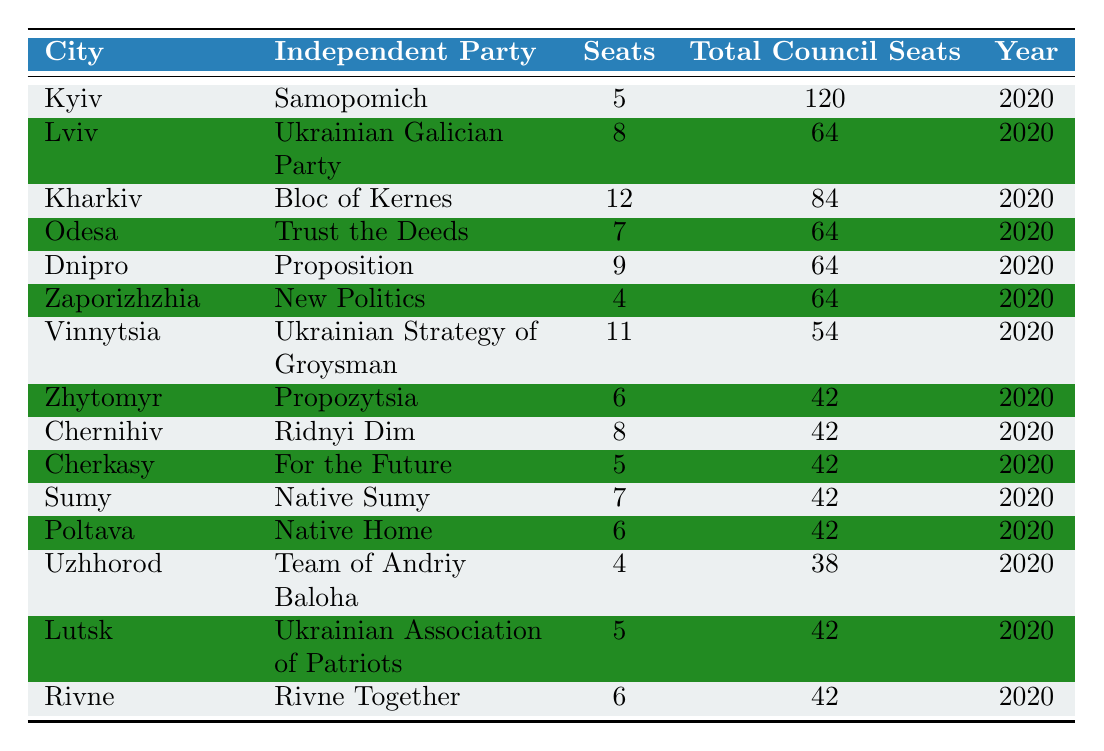What independent party has the most seats in Kharkiv? In the table, Kharkiv lists "Bloc of Kernes" with 12 seats. This is the highest number of seats among the independent parties in local councils mentioned in the table.
Answer: Bloc of Kernes Which city has the lowest representation of independent parties? The city with the lowest number of seats for an independent party is Zaporizhzhia, which has 4 seats.
Answer: Zaporizhzhia What is the total number of seats held by independent parties in Vinnytsia and Lviv combined? In Vinnytsia, the independent party has 11 seats and in Lviv, it has 8 seats. When added together, 11 + 8 = 19 seats are held by independent parties in these two cities.
Answer: 19 Is the total number of seats in Odesa greater than that in Dnipro? Odesa has 7 total seats while Dnipro has 9 total seats. Since 7 is less than 9, the statement is false.
Answer: No How many total council seats are represented by independent parties in all listed cities? To find this, we sum the total council seats for each city: 120 + 64 + 84 + 64 + 64 + 64 + 54 + 42 + 42 + 42 + 42 + 42 + 38 + 42 + 42 =  705 total council seats are represented across all cities.
Answer: 705 Which independent party in the table has the most seats relative to the total council seats in their city? The ratio of seats to total council seats for each party must be calculated: for Kharkiv's Bloc of Kernes: 12/84 = 0.14, and repeating this for others shows that Vinnytsia's Ukrainian Strategy of Groysman has 11/54 = 0.20. This is the highest ratio, indicating better representation.
Answer: Ukrainian Strategy of Groysman In which city do independent parties occupy more than 50% of the total council seats? To determine this, we check the ratio for each city. In Vinnytsia, independent parties hold 11 of 54 seats, about 20%, which is not more than 50%. However, the maximum is found in Kharkiv, where 12 of 84 seats equals 14.29%. Therefore, none exceed 50%.
Answer: None How many more seats does the independent party in Kharkiv have than that in Cherkasy? Kharkiv has 12 seats and Cherkasy has 5 seats. Thus, 12 - 5 = 7 more seats.
Answer: 7 What is the average number of seats held by independent parties in the cities listed? The average is calculated by summing all the seats (5 + 8 + 12 + 7 + 9 + 4 + 11 + 6 + 8 + 5 + 7 + 6 + 4 + 5 + 6 =  7) and dividing by the number of cities (15). Thus, the average number of seats is  105/15 = 7.
Answer: 7 